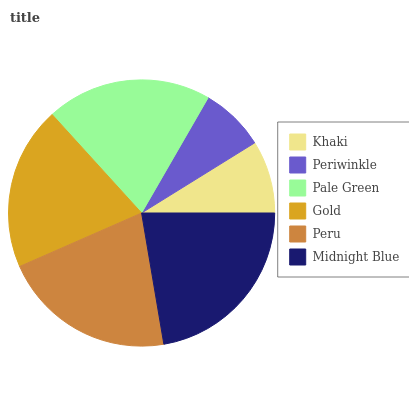Is Periwinkle the minimum?
Answer yes or no. Yes. Is Midnight Blue the maximum?
Answer yes or no. Yes. Is Pale Green the minimum?
Answer yes or no. No. Is Pale Green the maximum?
Answer yes or no. No. Is Pale Green greater than Periwinkle?
Answer yes or no. Yes. Is Periwinkle less than Pale Green?
Answer yes or no. Yes. Is Periwinkle greater than Pale Green?
Answer yes or no. No. Is Pale Green less than Periwinkle?
Answer yes or no. No. Is Pale Green the high median?
Answer yes or no. Yes. Is Gold the low median?
Answer yes or no. Yes. Is Gold the high median?
Answer yes or no. No. Is Midnight Blue the low median?
Answer yes or no. No. 